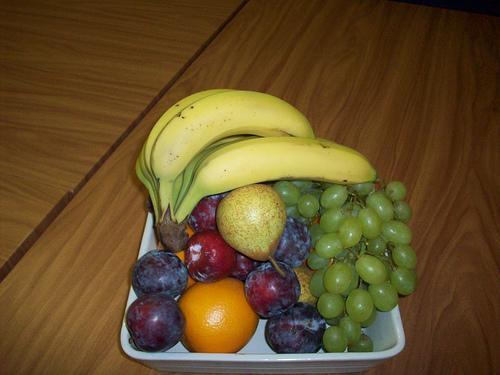How many different types of fruit are present?
Give a very brief answer. 5. How many bananas are in the basket?
Give a very brief answer. 6. How many pears are in front of the banana?
Give a very brief answer. 1. How many different types of fruits and vegetables here?
Give a very brief answer. 5. How many pictures of apples are there in this scene?
Give a very brief answer. 0. How many apples can you see?
Give a very brief answer. 4. How many zebras are shown?
Give a very brief answer. 0. 